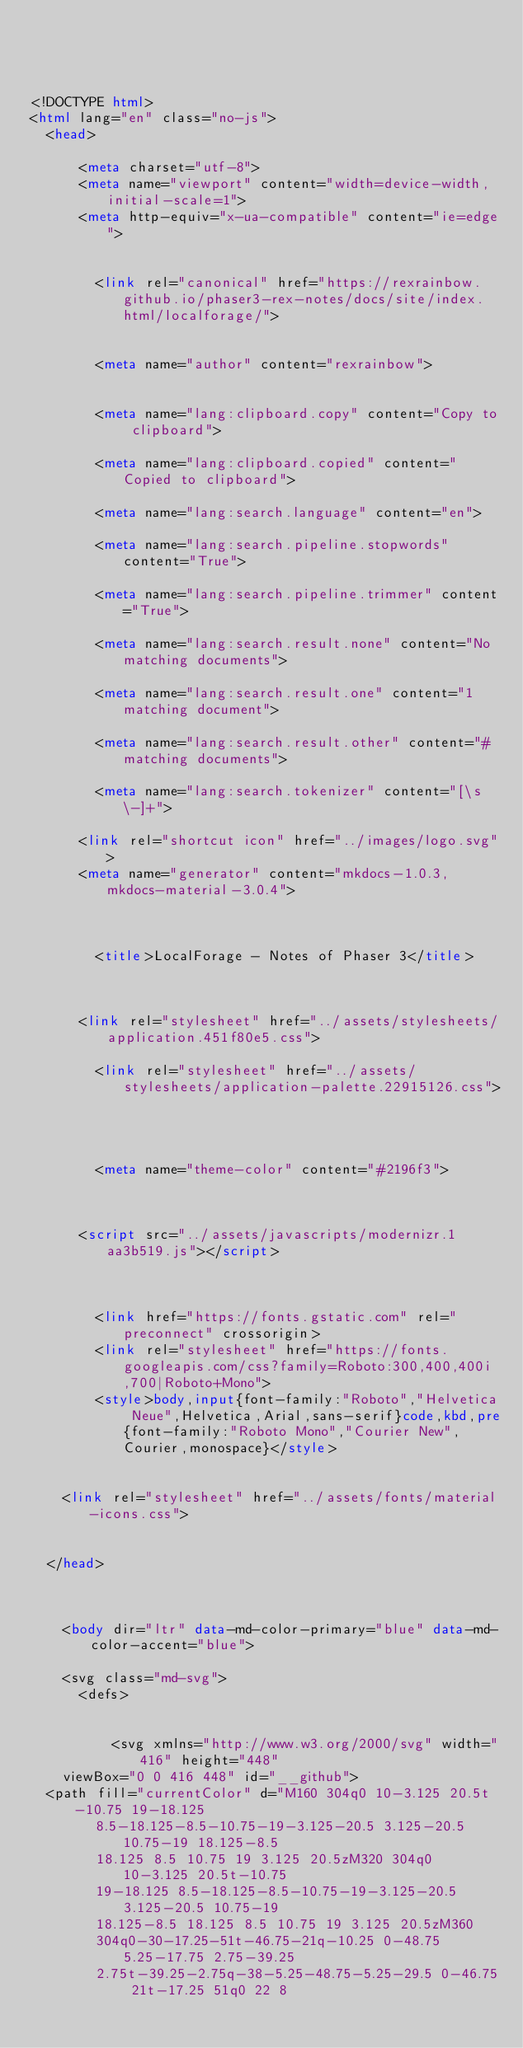Convert code to text. <code><loc_0><loc_0><loc_500><loc_500><_HTML_>



<!DOCTYPE html>
<html lang="en" class="no-js">
  <head>
    
      <meta charset="utf-8">
      <meta name="viewport" content="width=device-width,initial-scale=1">
      <meta http-equiv="x-ua-compatible" content="ie=edge">
      
      
        <link rel="canonical" href="https://rexrainbow.github.io/phaser3-rex-notes/docs/site/index.html/localforage/">
      
      
        <meta name="author" content="rexrainbow">
      
      
        <meta name="lang:clipboard.copy" content="Copy to clipboard">
      
        <meta name="lang:clipboard.copied" content="Copied to clipboard">
      
        <meta name="lang:search.language" content="en">
      
        <meta name="lang:search.pipeline.stopwords" content="True">
      
        <meta name="lang:search.pipeline.trimmer" content="True">
      
        <meta name="lang:search.result.none" content="No matching documents">
      
        <meta name="lang:search.result.one" content="1 matching document">
      
        <meta name="lang:search.result.other" content="# matching documents">
      
        <meta name="lang:search.tokenizer" content="[\s\-]+">
      
      <link rel="shortcut icon" href="../images/logo.svg">
      <meta name="generator" content="mkdocs-1.0.3, mkdocs-material-3.0.4">
    
    
      
        <title>LocalForage - Notes of Phaser 3</title>
      
    
    
      <link rel="stylesheet" href="../assets/stylesheets/application.451f80e5.css">
      
        <link rel="stylesheet" href="../assets/stylesheets/application-palette.22915126.css">
      
      
        
        
        <meta name="theme-color" content="#2196f3">
      
    
    
      <script src="../assets/javascripts/modernizr.1aa3b519.js"></script>
    
    
      
        <link href="https://fonts.gstatic.com" rel="preconnect" crossorigin>
        <link rel="stylesheet" href="https://fonts.googleapis.com/css?family=Roboto:300,400,400i,700|Roboto+Mono">
        <style>body,input{font-family:"Roboto","Helvetica Neue",Helvetica,Arial,sans-serif}code,kbd,pre{font-family:"Roboto Mono","Courier New",Courier,monospace}</style>
      
    
    <link rel="stylesheet" href="../assets/fonts/material-icons.css">
    
    
  </head>
  
    
    
    <body dir="ltr" data-md-color-primary="blue" data-md-color-accent="blue">
  
    <svg class="md-svg">
      <defs>
        
        
          <svg xmlns="http://www.w3.org/2000/svg" width="416" height="448"
    viewBox="0 0 416 448" id="__github">
  <path fill="currentColor" d="M160 304q0 10-3.125 20.5t-10.75 19-18.125
        8.5-18.125-8.5-10.75-19-3.125-20.5 3.125-20.5 10.75-19 18.125-8.5
        18.125 8.5 10.75 19 3.125 20.5zM320 304q0 10-3.125 20.5t-10.75
        19-18.125 8.5-18.125-8.5-10.75-19-3.125-20.5 3.125-20.5 10.75-19
        18.125-8.5 18.125 8.5 10.75 19 3.125 20.5zM360
        304q0-30-17.25-51t-46.75-21q-10.25 0-48.75 5.25-17.75 2.75-39.25
        2.75t-39.25-2.75q-38-5.25-48.75-5.25-29.5 0-46.75 21t-17.25 51q0 22 8</code> 